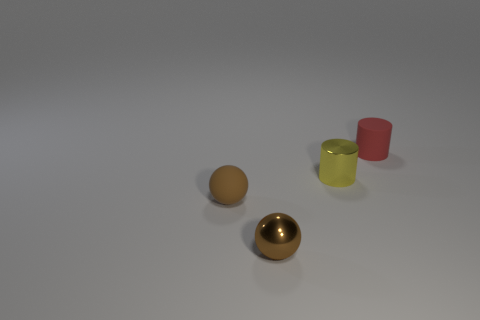Add 4 red objects. How many objects exist? 8 Add 1 tiny brown rubber spheres. How many tiny brown rubber spheres exist? 2 Subtract 0 green balls. How many objects are left? 4 Subtract all large purple things. Subtract all tiny brown objects. How many objects are left? 2 Add 4 tiny matte objects. How many tiny matte objects are left? 6 